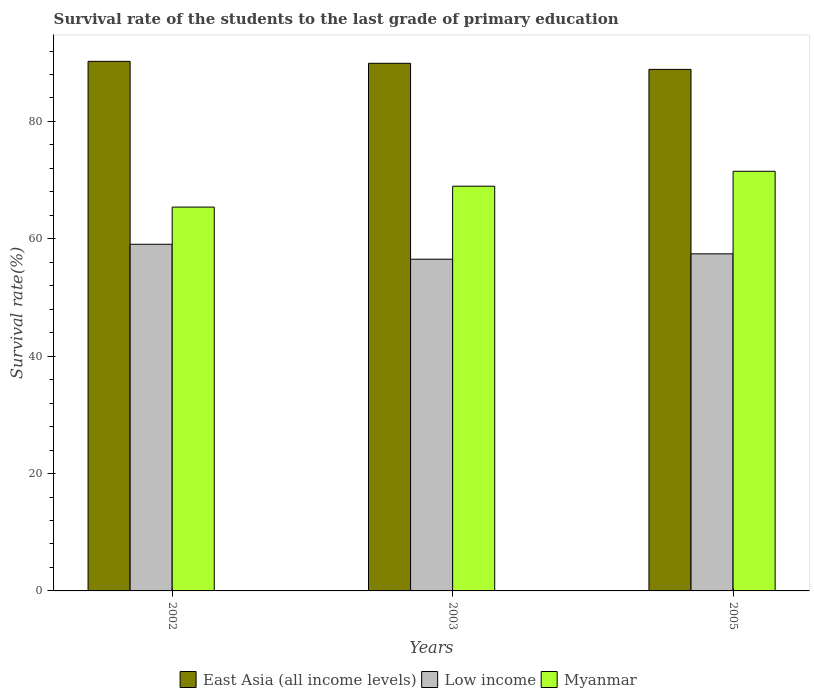How many different coloured bars are there?
Keep it short and to the point. 3. How many groups of bars are there?
Provide a succinct answer. 3. Are the number of bars on each tick of the X-axis equal?
Offer a very short reply. Yes. What is the label of the 2nd group of bars from the left?
Keep it short and to the point. 2003. In how many cases, is the number of bars for a given year not equal to the number of legend labels?
Provide a short and direct response. 0. What is the survival rate of the students in East Asia (all income levels) in 2005?
Provide a succinct answer. 88.87. Across all years, what is the maximum survival rate of the students in Myanmar?
Your response must be concise. 71.51. Across all years, what is the minimum survival rate of the students in Myanmar?
Provide a short and direct response. 65.4. In which year was the survival rate of the students in East Asia (all income levels) maximum?
Make the answer very short. 2002. What is the total survival rate of the students in Low income in the graph?
Give a very brief answer. 173.04. What is the difference between the survival rate of the students in East Asia (all income levels) in 2002 and that in 2005?
Your answer should be compact. 1.37. What is the difference between the survival rate of the students in East Asia (all income levels) in 2005 and the survival rate of the students in Low income in 2002?
Offer a terse response. 29.8. What is the average survival rate of the students in East Asia (all income levels) per year?
Make the answer very short. 89.67. In the year 2003, what is the difference between the survival rate of the students in East Asia (all income levels) and survival rate of the students in Myanmar?
Keep it short and to the point. 20.94. In how many years, is the survival rate of the students in East Asia (all income levels) greater than 56 %?
Give a very brief answer. 3. What is the ratio of the survival rate of the students in Low income in 2002 to that in 2003?
Ensure brevity in your answer.  1.05. Is the survival rate of the students in Low income in 2002 less than that in 2005?
Provide a succinct answer. No. Is the difference between the survival rate of the students in East Asia (all income levels) in 2003 and 2005 greater than the difference between the survival rate of the students in Myanmar in 2003 and 2005?
Give a very brief answer. Yes. What is the difference between the highest and the second highest survival rate of the students in Myanmar?
Your answer should be very brief. 2.55. What is the difference between the highest and the lowest survival rate of the students in Low income?
Your response must be concise. 2.55. Is it the case that in every year, the sum of the survival rate of the students in Low income and survival rate of the students in East Asia (all income levels) is greater than the survival rate of the students in Myanmar?
Offer a very short reply. Yes. How many years are there in the graph?
Your answer should be very brief. 3. Are the values on the major ticks of Y-axis written in scientific E-notation?
Your answer should be very brief. No. Does the graph contain any zero values?
Offer a terse response. No. Where does the legend appear in the graph?
Provide a short and direct response. Bottom center. How many legend labels are there?
Make the answer very short. 3. How are the legend labels stacked?
Make the answer very short. Horizontal. What is the title of the graph?
Offer a very short reply. Survival rate of the students to the last grade of primary education. Does "Slovak Republic" appear as one of the legend labels in the graph?
Keep it short and to the point. No. What is the label or title of the X-axis?
Your answer should be compact. Years. What is the label or title of the Y-axis?
Keep it short and to the point. Survival rate(%). What is the Survival rate(%) of East Asia (all income levels) in 2002?
Keep it short and to the point. 90.24. What is the Survival rate(%) in Low income in 2002?
Provide a succinct answer. 59.07. What is the Survival rate(%) of Myanmar in 2002?
Provide a succinct answer. 65.4. What is the Survival rate(%) of East Asia (all income levels) in 2003?
Provide a succinct answer. 89.91. What is the Survival rate(%) in Low income in 2003?
Offer a very short reply. 56.53. What is the Survival rate(%) in Myanmar in 2003?
Keep it short and to the point. 68.96. What is the Survival rate(%) of East Asia (all income levels) in 2005?
Keep it short and to the point. 88.87. What is the Survival rate(%) in Low income in 2005?
Your response must be concise. 57.44. What is the Survival rate(%) in Myanmar in 2005?
Your response must be concise. 71.51. Across all years, what is the maximum Survival rate(%) in East Asia (all income levels)?
Your answer should be very brief. 90.24. Across all years, what is the maximum Survival rate(%) of Low income?
Your response must be concise. 59.07. Across all years, what is the maximum Survival rate(%) in Myanmar?
Provide a short and direct response. 71.51. Across all years, what is the minimum Survival rate(%) in East Asia (all income levels)?
Give a very brief answer. 88.87. Across all years, what is the minimum Survival rate(%) of Low income?
Keep it short and to the point. 56.53. Across all years, what is the minimum Survival rate(%) of Myanmar?
Provide a succinct answer. 65.4. What is the total Survival rate(%) in East Asia (all income levels) in the graph?
Keep it short and to the point. 269.02. What is the total Survival rate(%) in Low income in the graph?
Provide a succinct answer. 173.04. What is the total Survival rate(%) of Myanmar in the graph?
Your answer should be compact. 205.88. What is the difference between the Survival rate(%) in East Asia (all income levels) in 2002 and that in 2003?
Provide a short and direct response. 0.33. What is the difference between the Survival rate(%) in Low income in 2002 and that in 2003?
Give a very brief answer. 2.55. What is the difference between the Survival rate(%) in Myanmar in 2002 and that in 2003?
Keep it short and to the point. -3.56. What is the difference between the Survival rate(%) in East Asia (all income levels) in 2002 and that in 2005?
Offer a very short reply. 1.37. What is the difference between the Survival rate(%) in Low income in 2002 and that in 2005?
Provide a short and direct response. 1.63. What is the difference between the Survival rate(%) in Myanmar in 2002 and that in 2005?
Your answer should be compact. -6.11. What is the difference between the Survival rate(%) in East Asia (all income levels) in 2003 and that in 2005?
Your answer should be very brief. 1.04. What is the difference between the Survival rate(%) in Low income in 2003 and that in 2005?
Offer a very short reply. -0.92. What is the difference between the Survival rate(%) of Myanmar in 2003 and that in 2005?
Make the answer very short. -2.55. What is the difference between the Survival rate(%) in East Asia (all income levels) in 2002 and the Survival rate(%) in Low income in 2003?
Your answer should be compact. 33.72. What is the difference between the Survival rate(%) in East Asia (all income levels) in 2002 and the Survival rate(%) in Myanmar in 2003?
Ensure brevity in your answer.  21.28. What is the difference between the Survival rate(%) of Low income in 2002 and the Survival rate(%) of Myanmar in 2003?
Your answer should be very brief. -9.89. What is the difference between the Survival rate(%) of East Asia (all income levels) in 2002 and the Survival rate(%) of Low income in 2005?
Make the answer very short. 32.8. What is the difference between the Survival rate(%) of East Asia (all income levels) in 2002 and the Survival rate(%) of Myanmar in 2005?
Your answer should be very brief. 18.73. What is the difference between the Survival rate(%) of Low income in 2002 and the Survival rate(%) of Myanmar in 2005?
Ensure brevity in your answer.  -12.44. What is the difference between the Survival rate(%) in East Asia (all income levels) in 2003 and the Survival rate(%) in Low income in 2005?
Provide a succinct answer. 32.47. What is the difference between the Survival rate(%) in East Asia (all income levels) in 2003 and the Survival rate(%) in Myanmar in 2005?
Your answer should be compact. 18.4. What is the difference between the Survival rate(%) of Low income in 2003 and the Survival rate(%) of Myanmar in 2005?
Give a very brief answer. -14.98. What is the average Survival rate(%) of East Asia (all income levels) per year?
Provide a succinct answer. 89.67. What is the average Survival rate(%) of Low income per year?
Make the answer very short. 57.68. What is the average Survival rate(%) of Myanmar per year?
Your answer should be very brief. 68.63. In the year 2002, what is the difference between the Survival rate(%) in East Asia (all income levels) and Survival rate(%) in Low income?
Your answer should be very brief. 31.17. In the year 2002, what is the difference between the Survival rate(%) in East Asia (all income levels) and Survival rate(%) in Myanmar?
Your answer should be compact. 24.84. In the year 2002, what is the difference between the Survival rate(%) in Low income and Survival rate(%) in Myanmar?
Your response must be concise. -6.33. In the year 2003, what is the difference between the Survival rate(%) of East Asia (all income levels) and Survival rate(%) of Low income?
Your answer should be compact. 33.38. In the year 2003, what is the difference between the Survival rate(%) in East Asia (all income levels) and Survival rate(%) in Myanmar?
Offer a terse response. 20.94. In the year 2003, what is the difference between the Survival rate(%) in Low income and Survival rate(%) in Myanmar?
Your answer should be very brief. -12.44. In the year 2005, what is the difference between the Survival rate(%) of East Asia (all income levels) and Survival rate(%) of Low income?
Keep it short and to the point. 31.43. In the year 2005, what is the difference between the Survival rate(%) in East Asia (all income levels) and Survival rate(%) in Myanmar?
Provide a succinct answer. 17.36. In the year 2005, what is the difference between the Survival rate(%) of Low income and Survival rate(%) of Myanmar?
Your answer should be compact. -14.07. What is the ratio of the Survival rate(%) in East Asia (all income levels) in 2002 to that in 2003?
Your response must be concise. 1. What is the ratio of the Survival rate(%) of Low income in 2002 to that in 2003?
Your answer should be very brief. 1.05. What is the ratio of the Survival rate(%) in Myanmar in 2002 to that in 2003?
Offer a very short reply. 0.95. What is the ratio of the Survival rate(%) of East Asia (all income levels) in 2002 to that in 2005?
Ensure brevity in your answer.  1.02. What is the ratio of the Survival rate(%) of Low income in 2002 to that in 2005?
Give a very brief answer. 1.03. What is the ratio of the Survival rate(%) of Myanmar in 2002 to that in 2005?
Ensure brevity in your answer.  0.91. What is the ratio of the Survival rate(%) of East Asia (all income levels) in 2003 to that in 2005?
Provide a short and direct response. 1.01. What is the ratio of the Survival rate(%) in Low income in 2003 to that in 2005?
Offer a very short reply. 0.98. What is the ratio of the Survival rate(%) in Myanmar in 2003 to that in 2005?
Provide a short and direct response. 0.96. What is the difference between the highest and the second highest Survival rate(%) of East Asia (all income levels)?
Offer a terse response. 0.33. What is the difference between the highest and the second highest Survival rate(%) of Low income?
Your answer should be compact. 1.63. What is the difference between the highest and the second highest Survival rate(%) of Myanmar?
Offer a terse response. 2.55. What is the difference between the highest and the lowest Survival rate(%) in East Asia (all income levels)?
Offer a terse response. 1.37. What is the difference between the highest and the lowest Survival rate(%) of Low income?
Your response must be concise. 2.55. What is the difference between the highest and the lowest Survival rate(%) of Myanmar?
Provide a succinct answer. 6.11. 